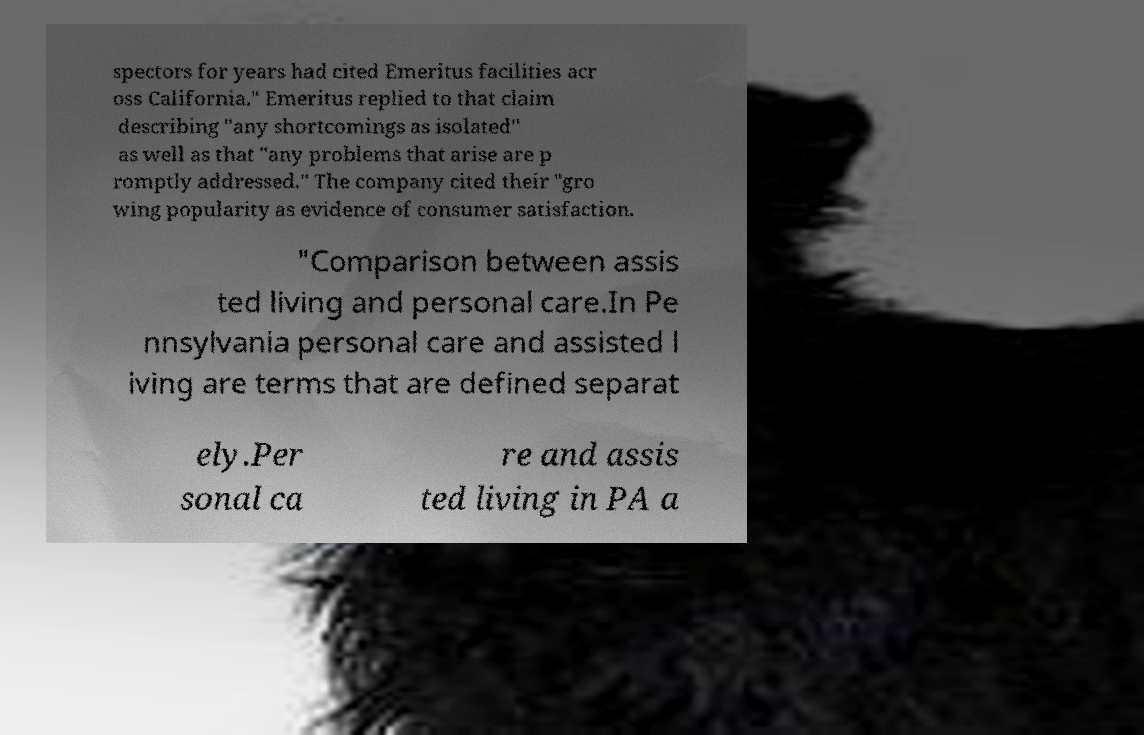I need the written content from this picture converted into text. Can you do that? spectors for years had cited Emeritus facilities acr oss California." Emeritus replied to that claim describing "any shortcomings as isolated" as well as that "any problems that arise are p romptly addressed." The company cited their "gro wing popularity as evidence of consumer satisfaction. "Comparison between assis ted living and personal care.In Pe nnsylvania personal care and assisted l iving are terms that are defined separat ely.Per sonal ca re and assis ted living in PA a 